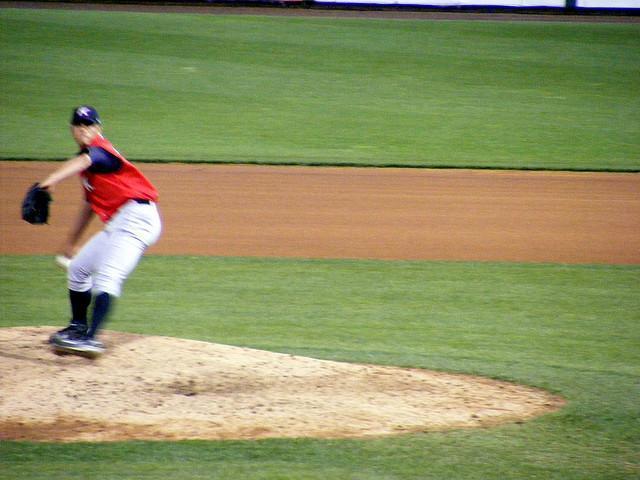How many people are in the picture?
Give a very brief answer. 1. 